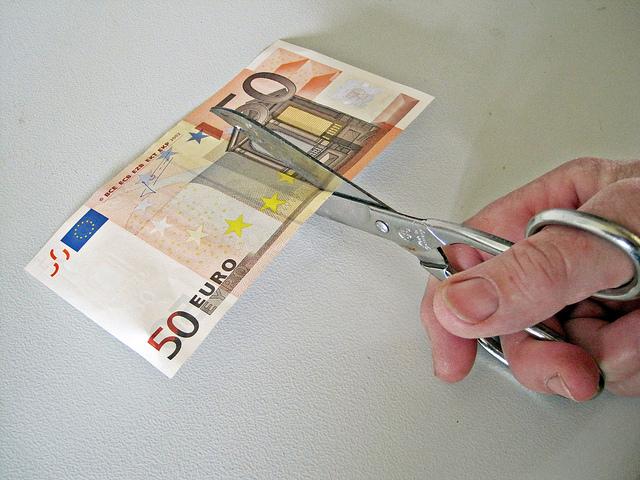What is being used to cut?
Quick response, please. Scissors. Is this person wasting money?
Keep it brief. Yes. What denomination is the bill?
Short answer required. 50. When this dollar bill is cut in half, is it still legal tender?
Write a very short answer. No. 